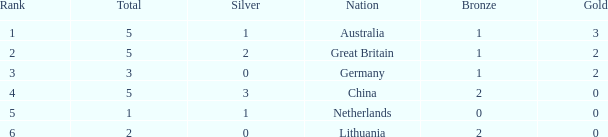If bronze is less than 1 and gold is more than 0, what is the average of silver? None. 